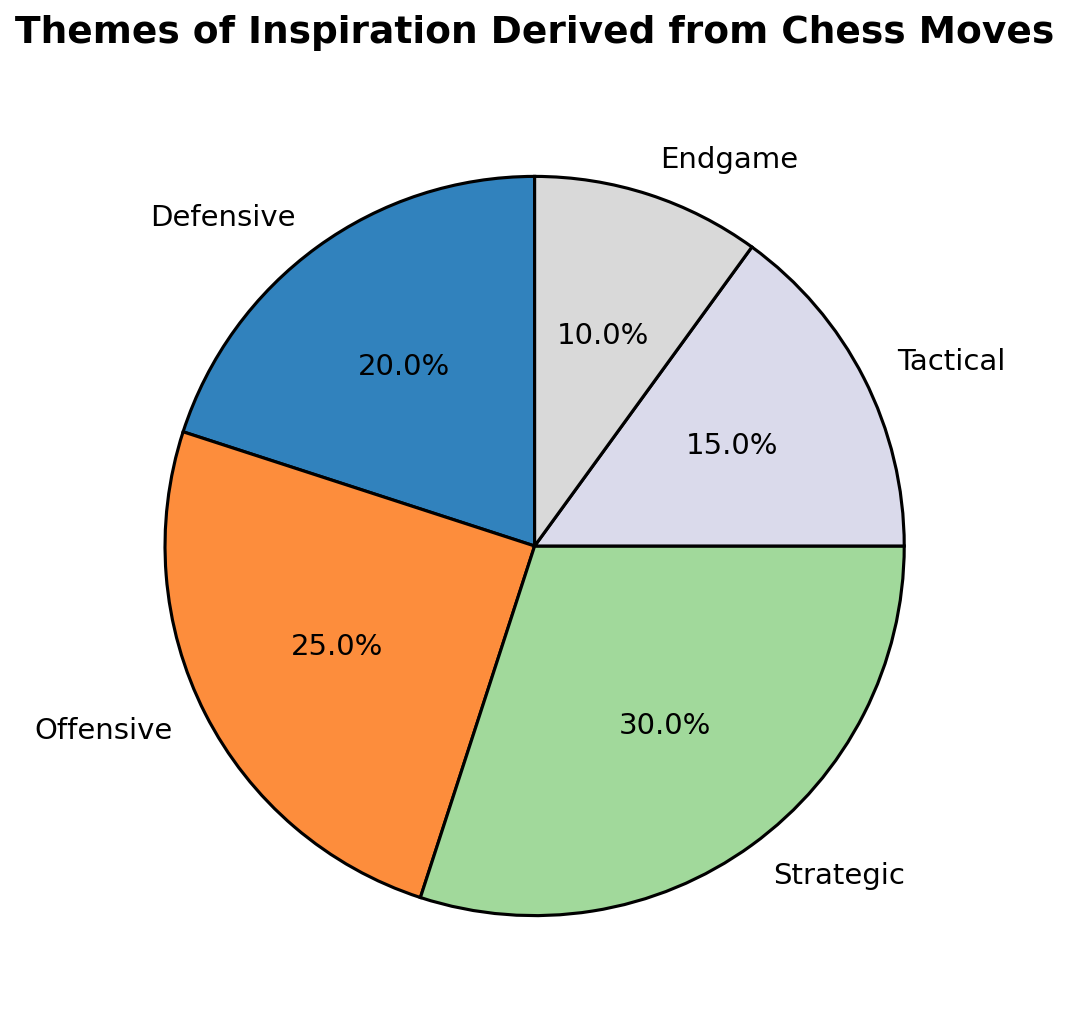Which theme has the largest percentage? By looking at the pie chart, we can compare the sizes of the wedges representing each theme. The "Strategic" theme has the largest wedge, which means it has the largest percentage.
Answer: Strategic Which theme has the smallest percentage? By comparing the wedges in the pie chart, the "Endgame" theme has the smallest wedge, indicating it has the smallest percentage.
Answer: Endgame What is the combined percentage of Defensive and Offensive themes? From the pie chart, the Defensive theme is 20% and the Offensive theme is 25%. Summing these percentages gives us 20% + 25% = 45%.
Answer: 45% What is the difference in percentage between the Strategic theme and the Endgame theme? The Strategic theme has 30%, and the Endgame theme has 10%. The difference is calculated as 30% - 10% = 20%.
Answer: 20% Is the proportion of the Strategic theme greater than the sum of Tactical and Endgame themes? The Strategic theme is 30%. The Tactical theme is 15%, and the Endgame theme is 10%. Summing Tactical and Endgame gives 15% + 10% = 25%. Since 30% is greater than 25%, the Strategic theme has a greater proportion.
Answer: Yes Which themes together constitute half of the total pie? The total pie is 100%. Half of it is 50%. The Strategic theme is 30%, and adding the Offensive theme (25%) makes it 30% + 25% = 55%. Therefore, the Strategic and Offensive themes together exceed half of the pie. To be exact, combining the two smallest themes, Endgame (10%) and Tactical (15%), with the Defensive theme (20%) reaches 45%, but this does not make half. Hence, the themes Defensive and Offensive together (45%) are closest, but only Strategic and Offensive themes together constitute 55%.
Answer: Strategic and Offensive List the themes in descending order of their percentages. From the pie chart, we see the percentages for each theme and order them from largest to smallest: (1) Strategic (30%), (2) Offensive (25%), (3) Defensive (20%), (4) Tactical (15%), and (5) Endgame (10%).
Answer: Strategic, Offensive, Defensive, Tactical, Endgame How many themes have a percentage greater than or equal to 20%? By examining the pie chart, we see that Strategic is 30%, Offensive is 25%, and Defensive is 20%. These three themes have percentages greater than or equal to 20%.
Answer: 3 